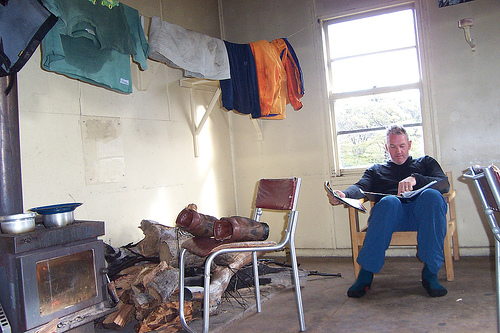<image>
Is the man next to the clothes? Yes. The man is positioned adjacent to the clothes, located nearby in the same general area. Where is the window in relation to the man? Is it behind the man? Yes. From this viewpoint, the window is positioned behind the man, with the man partially or fully occluding the window. 